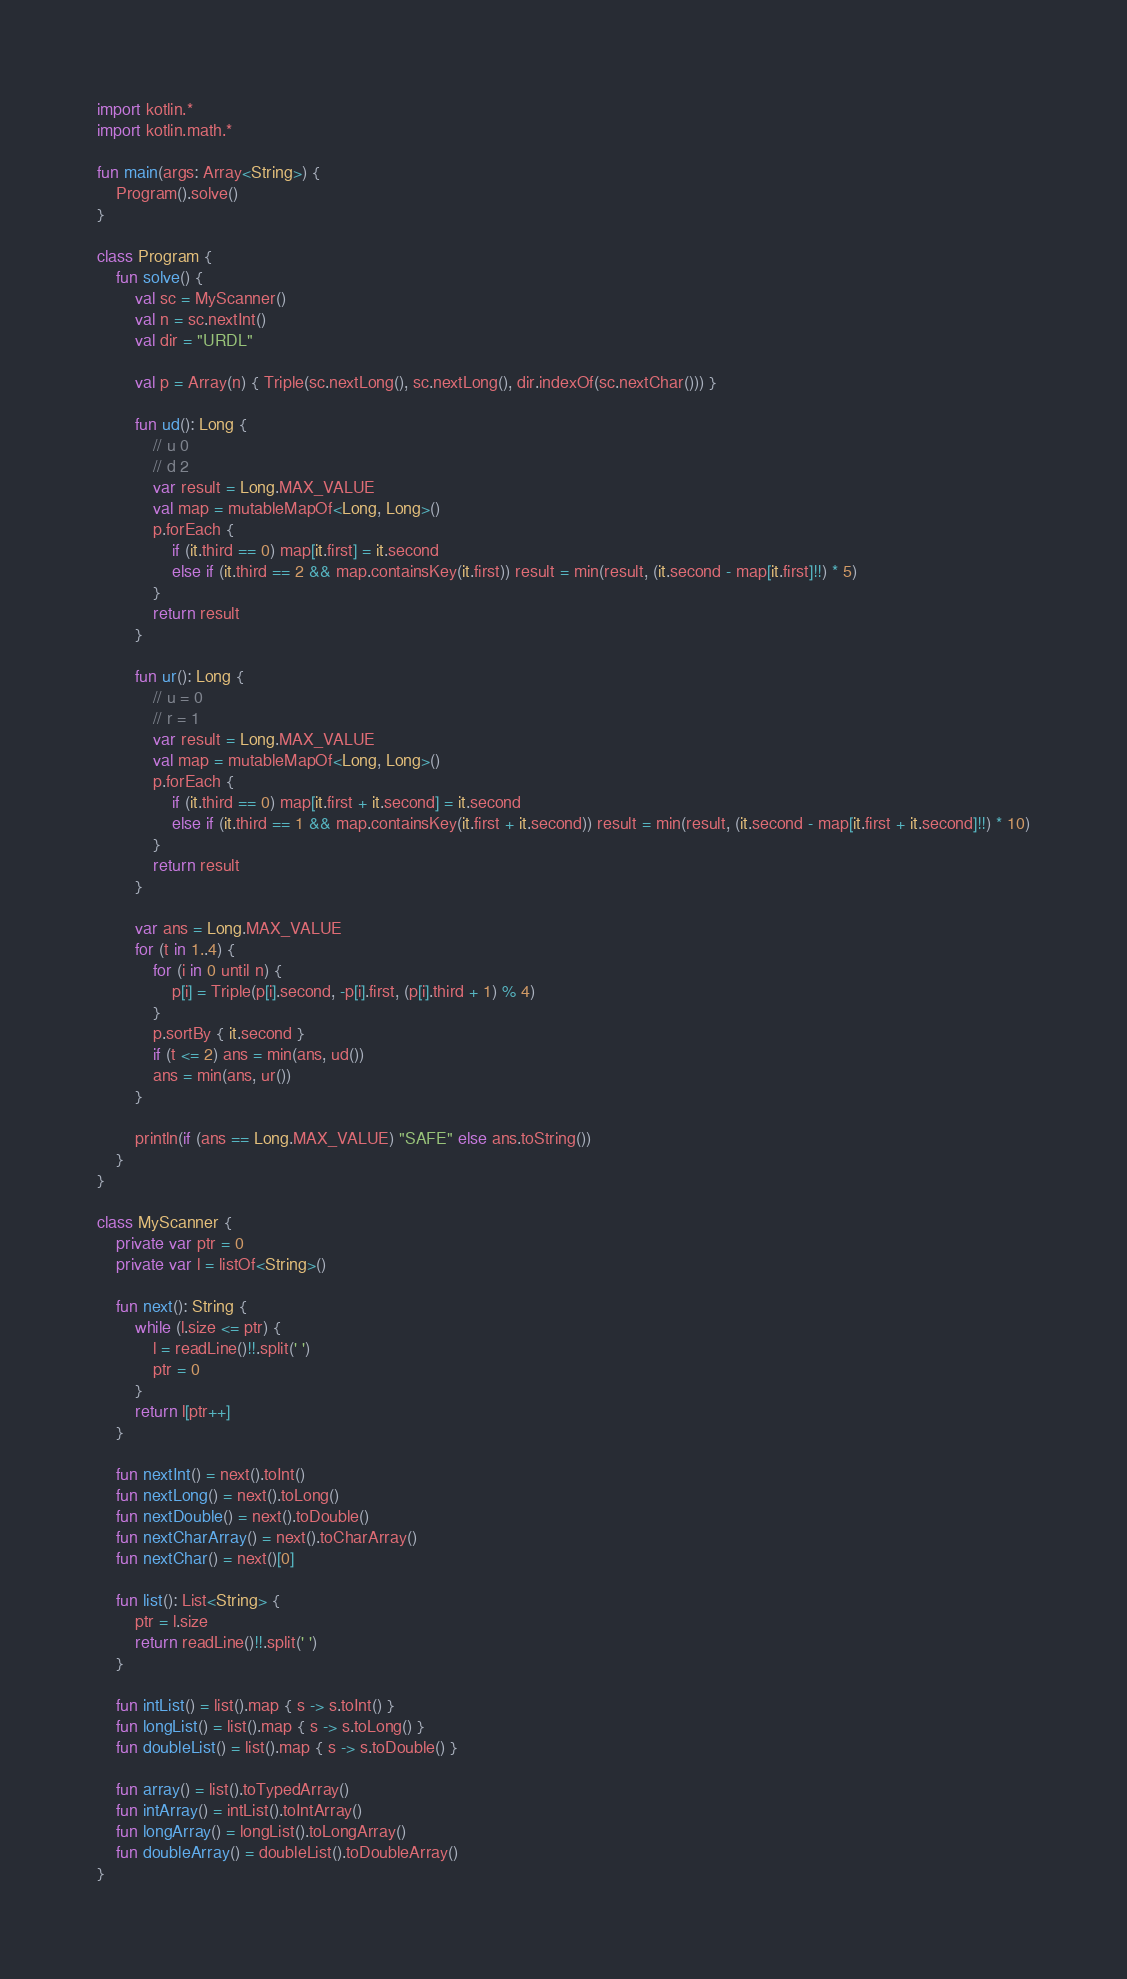<code> <loc_0><loc_0><loc_500><loc_500><_Kotlin_>import kotlin.*
import kotlin.math.*

fun main(args: Array<String>) {
    Program().solve()
}

class Program {
    fun solve() {
        val sc = MyScanner()
        val n = sc.nextInt()
        val dir = "URDL"

        val p = Array(n) { Triple(sc.nextLong(), sc.nextLong(), dir.indexOf(sc.nextChar())) }

        fun ud(): Long {
            // u 0
            // d 2
            var result = Long.MAX_VALUE
            val map = mutableMapOf<Long, Long>()
            p.forEach {
                if (it.third == 0) map[it.first] = it.second
                else if (it.third == 2 && map.containsKey(it.first)) result = min(result, (it.second - map[it.first]!!) * 5)
            }
            return result
        }

        fun ur(): Long {
            // u = 0
            // r = 1
            var result = Long.MAX_VALUE
            val map = mutableMapOf<Long, Long>()
            p.forEach {
                if (it.third == 0) map[it.first + it.second] = it.second
                else if (it.third == 1 && map.containsKey(it.first + it.second)) result = min(result, (it.second - map[it.first + it.second]!!) * 10)
            }
            return result
        }

        var ans = Long.MAX_VALUE
        for (t in 1..4) {
            for (i in 0 until n) {
                p[i] = Triple(p[i].second, -p[i].first, (p[i].third + 1) % 4)
            }
            p.sortBy { it.second }
            if (t <= 2) ans = min(ans, ud())
            ans = min(ans, ur())
        }

        println(if (ans == Long.MAX_VALUE) "SAFE" else ans.toString())
    }
}

class MyScanner {
    private var ptr = 0
    private var l = listOf<String>()

    fun next(): String {
        while (l.size <= ptr) {
            l = readLine()!!.split(' ')
            ptr = 0
        }
        return l[ptr++]
    }

    fun nextInt() = next().toInt()
    fun nextLong() = next().toLong()
    fun nextDouble() = next().toDouble()
    fun nextCharArray() = next().toCharArray()
    fun nextChar() = next()[0]

    fun list(): List<String> {
        ptr = l.size
        return readLine()!!.split(' ')
    }

    fun intList() = list().map { s -> s.toInt() }
    fun longList() = list().map { s -> s.toLong() }
    fun doubleList() = list().map { s -> s.toDouble() }

    fun array() = list().toTypedArray()
    fun intArray() = intList().toIntArray()
    fun longArray() = longList().toLongArray()
    fun doubleArray() = doubleList().toDoubleArray()
}
</code> 